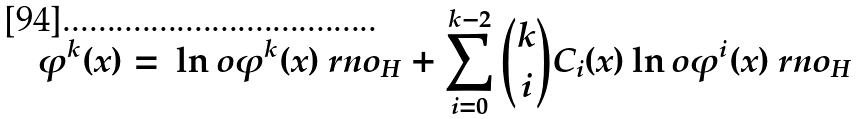<formula> <loc_0><loc_0><loc_500><loc_500>\varphi ^ { k } ( x ) = \, \ln o \varphi ^ { k } ( x ) \ r n o _ { H } + \sum _ { i = 0 } ^ { k - 2 } { k \choose i } C _ { i } ( x ) \ln o \varphi ^ { i } ( x ) \ r n o _ { H }</formula> 